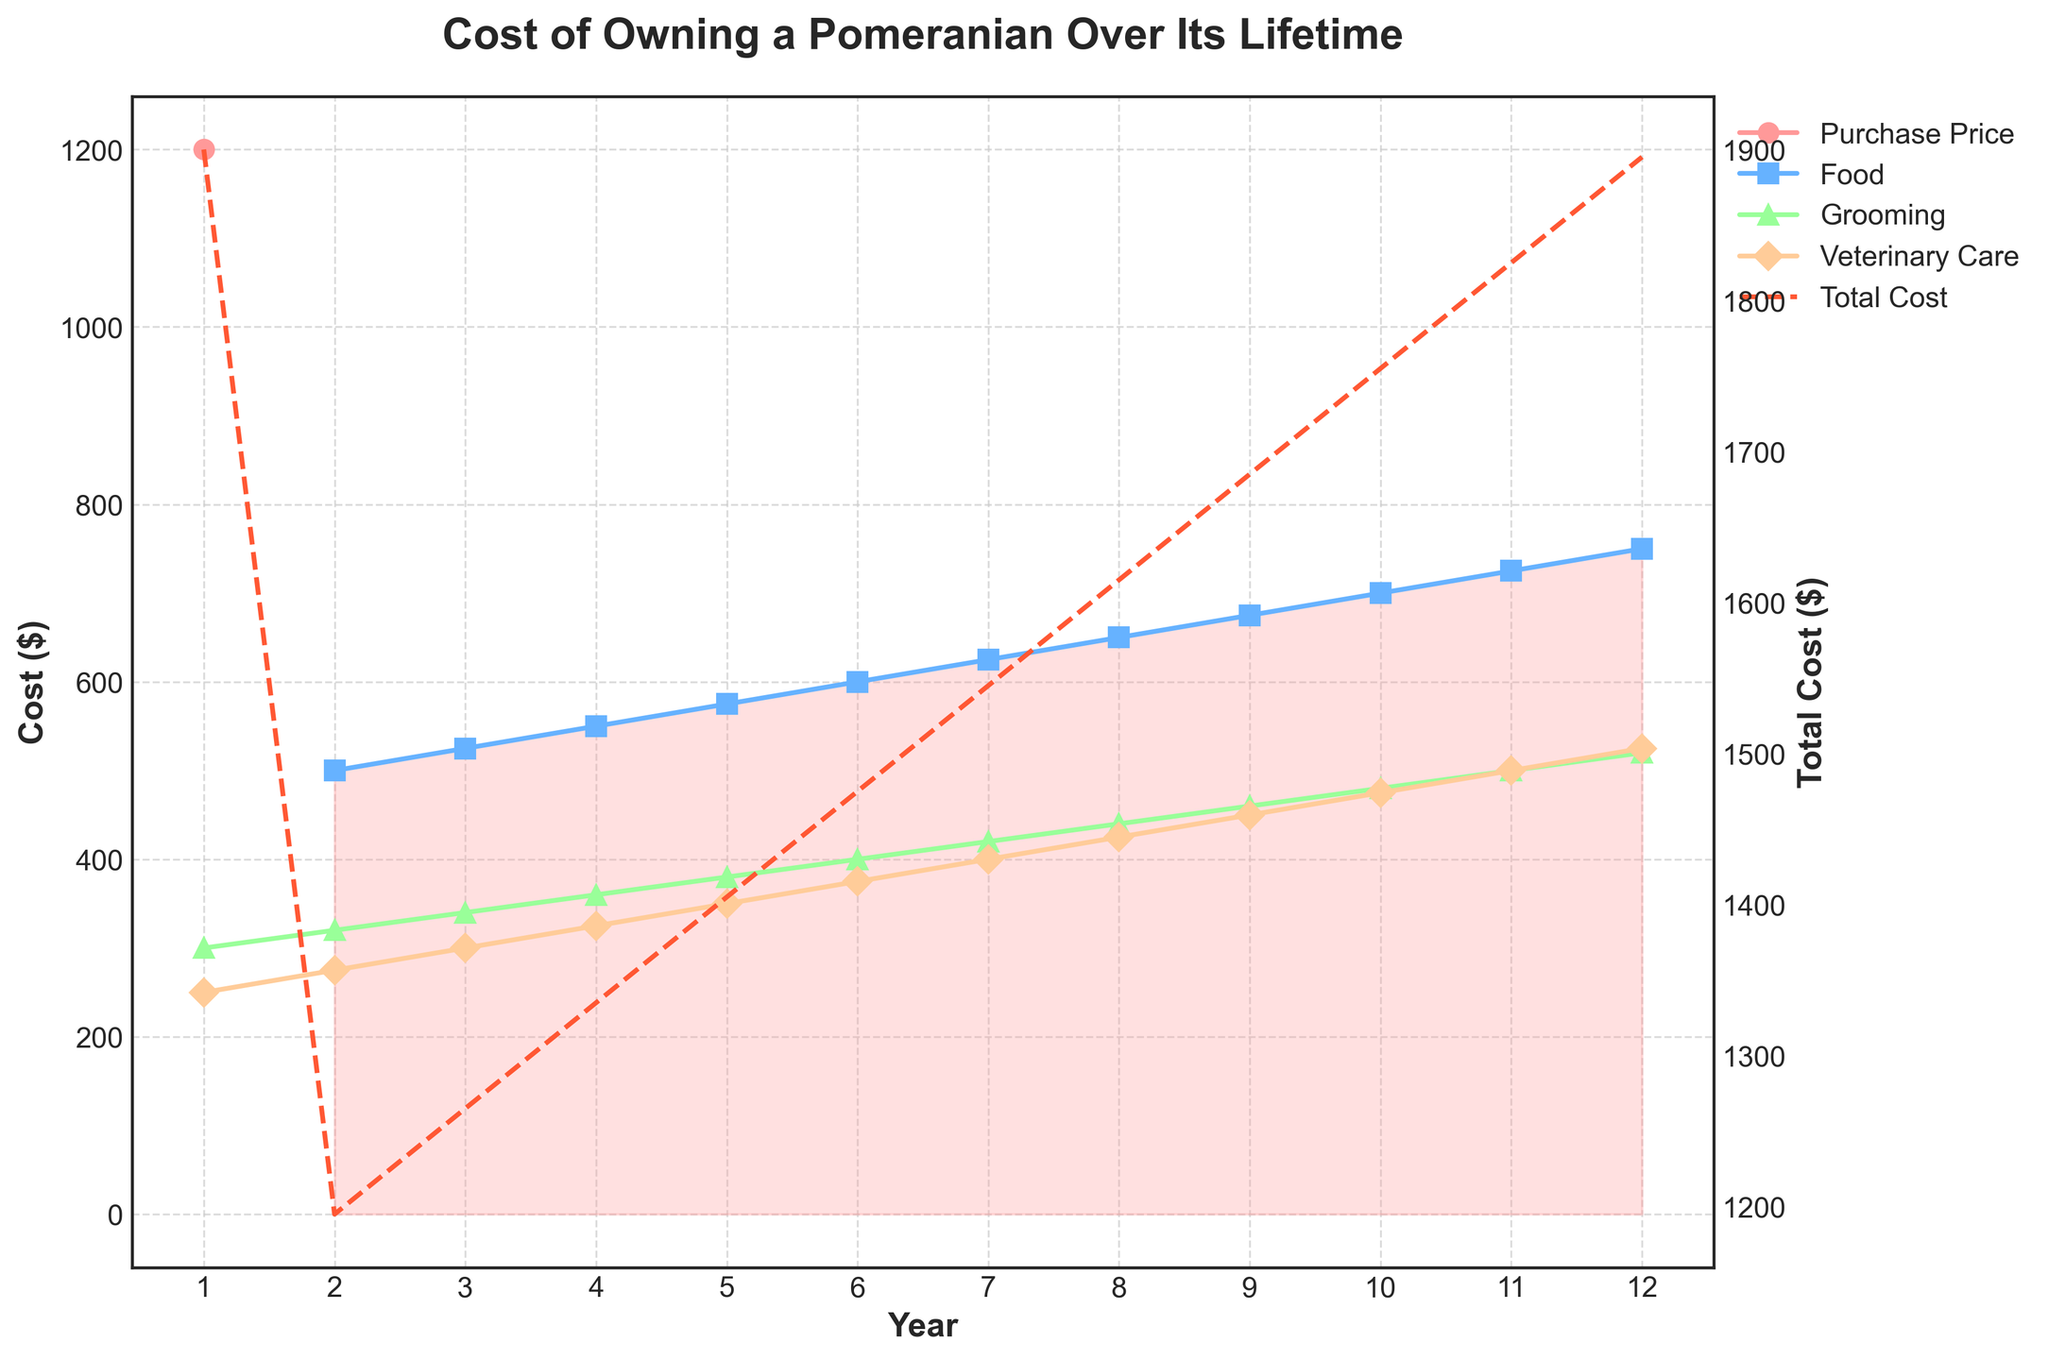Which expense starts the highest in the first year? To find the highest starting expense in the first year, look at the costs associated with each expense in year 1. Comparing the values, the Purchase Price is the highest at $1200.
Answer: Purchase Price ($1200) How does the total cost trend over the 12 years? Observe the dashed line representing the Total Cost. The line shows an upward trend, indicating that the total cost increases steadily over the years.
Answer: Increases steadily Which expense shows the sharpest increase over time? Analyze the slopes of the lines for each expense. The Food expense shows a consistent but less steep increase, Veterinary Care also increases steadily, but Grooming's line has a steeper slope, indicating the sharpest rise.
Answer: Grooming What is the total cost at the end of the 12 years? Look at the endpoint of the dashed Total Cost line. The value where it meets year 12 indicates the total cost at that point, which is around $3,795.
Answer: $3,795 What is the difference in the cost for food from year 1 to year 12? Find the cost of food in year 1 ($500) and in year 12 ($750). Subtract the two values to get the difference: $750 - $500 = $250.
Answer: $250 Compare the costs of grooming and veterinary care in year 6. Which is higher? In year 6, check the costs for Grooming ($400) and Veterinary Care ($375). Grooming is higher by $25.
Answer: Grooming ($400) During which year do the costs of grooming and veterinary care equal each other? Check the lines for Grooming and Veterinary Care. They intersect at year 9, where both costs are $450.
Answer: Year 9 What is the average annual cost of toys and accessories over the 12 years? The cost of Toys and Accessories remains constant at $100 from year 2 to year 12. Include year 1 ($150) in the total: (150 + (100*11))/12 = (150 + 1100)/12 = 1250/12 ≈ $104.17.
Answer: $104.17 Which expense shows the least variation over the 12 years? Look at the consistency of the lines. The Toys and Accessories expense remains almost flat at $100 from year 2 to year 12 with no variation.
Answer: Toys and Accessories What is the cumulative cost of veterinary care by year 5? Sum the costs for Veterinary Care from year 1 to year 5: $250 (year 1) + $275 (year 2) + $300 (year 3) + $325 (year 4) + $350 (year 5) = $1,500.
Answer: $1,500 